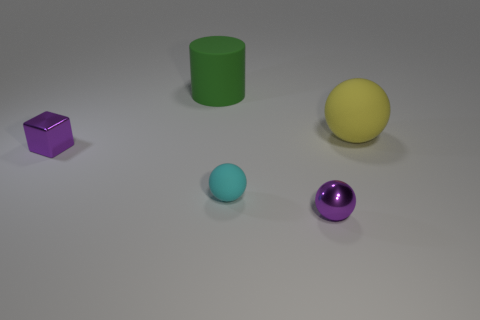Subtract all big rubber balls. How many balls are left? 2 Subtract 1 cylinders. How many cylinders are left? 0 Add 4 cylinders. How many objects exist? 9 Subtract all yellow balls. How many balls are left? 2 Subtract 0 blue blocks. How many objects are left? 5 Subtract all balls. How many objects are left? 2 Subtract all red balls. Subtract all purple blocks. How many balls are left? 3 Subtract all blue cylinders. How many blue blocks are left? 0 Subtract all large purple metallic spheres. Subtract all small rubber balls. How many objects are left? 4 Add 4 tiny purple objects. How many tiny purple objects are left? 6 